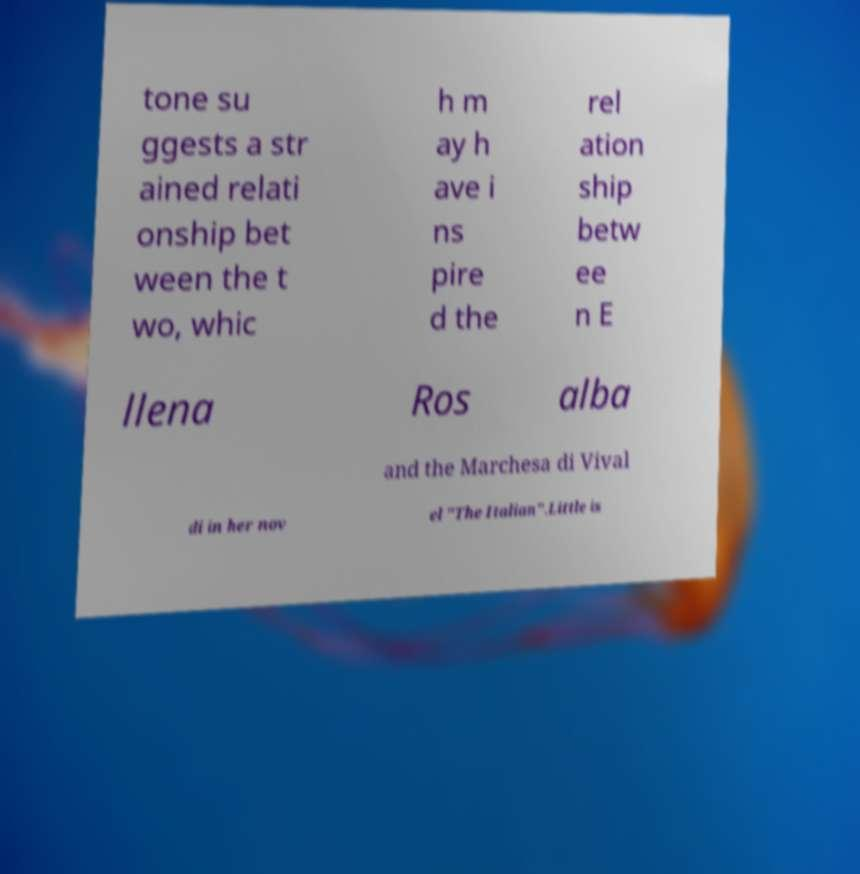There's text embedded in this image that I need extracted. Can you transcribe it verbatim? tone su ggests a str ained relati onship bet ween the t wo, whic h m ay h ave i ns pire d the rel ation ship betw ee n E llena Ros alba and the Marchesa di Vival di in her nov el "The Italian".Little is 